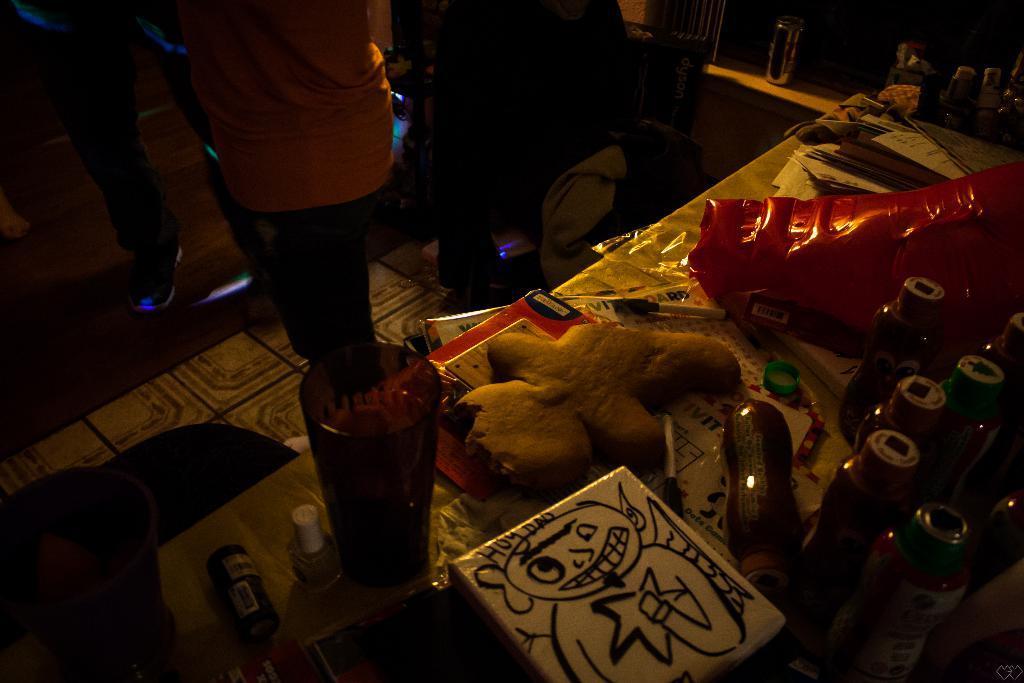Could you give a brief overview of what you see in this image? In this image we can see persons standing on the floor and a table is placed beside them. On the table there are nail polishes, tumblers, plastic bottles, pen, toys and books. 